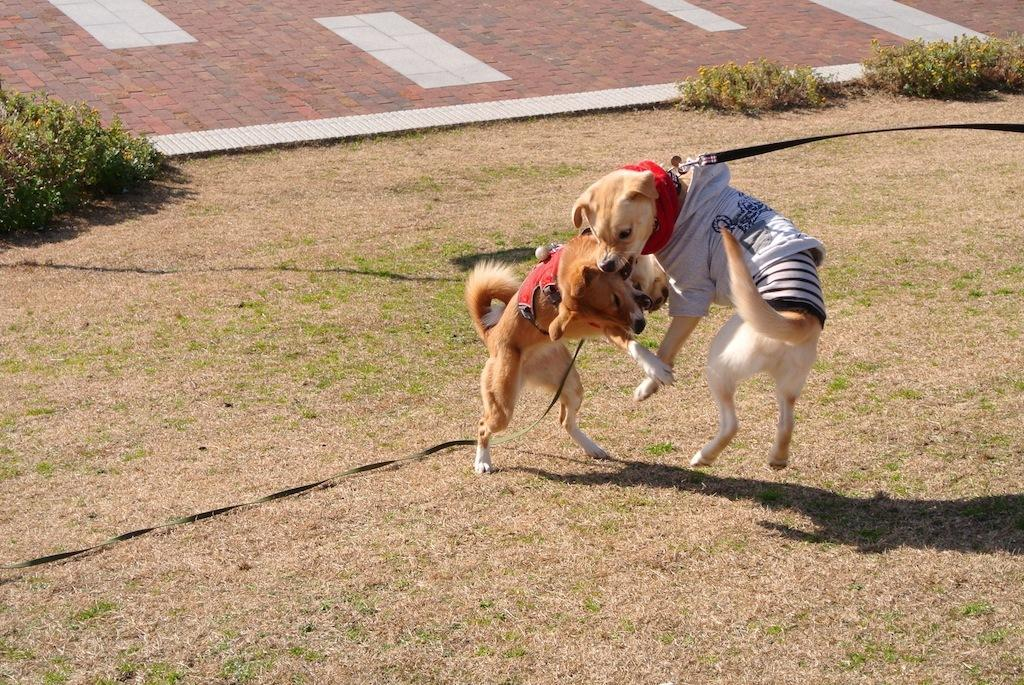How many dogs are present in the image? There are two dogs in the image. What are the dogs doing in the image? The dogs appear to be fighting. What type of surface is at the bottom of the image? There is grass at the bottom of the image. What can be seen in the middle of the image? There are plants in the middle of the image. What type of flooring is visible in the background of the image? There are tiles visible in the background of the image. What type of rail can be seen connecting the two dogs in the image? There is no rail present in the image, and the dogs are not connected by any object. 